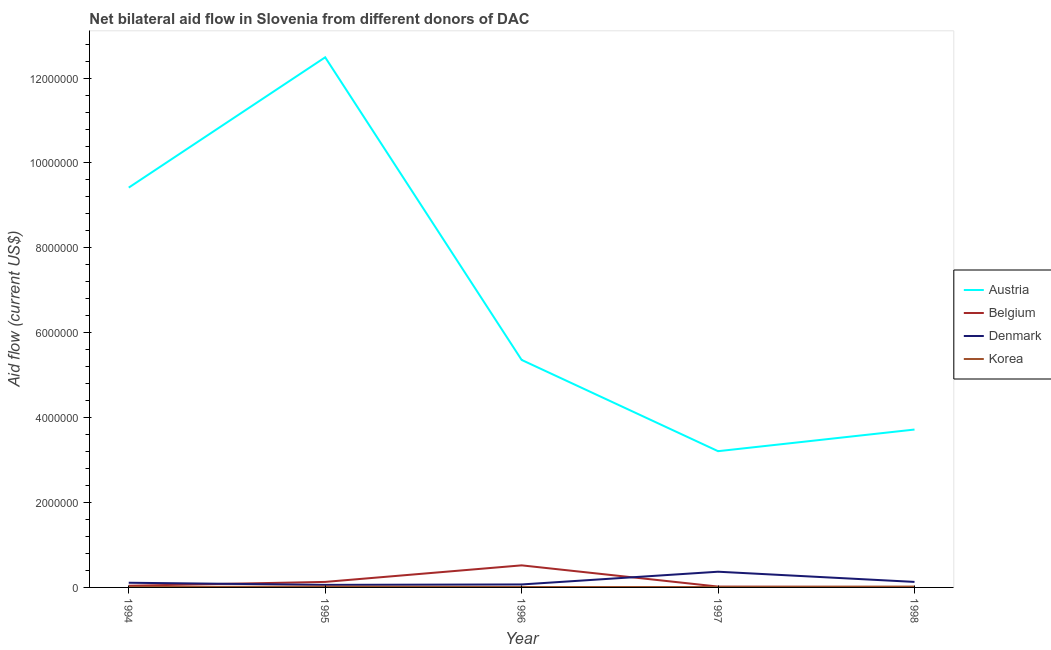Does the line corresponding to amount of aid given by austria intersect with the line corresponding to amount of aid given by korea?
Your answer should be compact. No. Is the number of lines equal to the number of legend labels?
Keep it short and to the point. Yes. What is the amount of aid given by austria in 1995?
Your answer should be compact. 1.25e+07. Across all years, what is the maximum amount of aid given by austria?
Make the answer very short. 1.25e+07. Across all years, what is the minimum amount of aid given by korea?
Your answer should be very brief. 10000. In which year was the amount of aid given by austria maximum?
Your answer should be very brief. 1995. What is the total amount of aid given by austria in the graph?
Provide a short and direct response. 3.42e+07. What is the difference between the amount of aid given by austria in 1996 and that in 1998?
Your response must be concise. 1.64e+06. What is the difference between the amount of aid given by denmark in 1996 and the amount of aid given by korea in 1994?
Ensure brevity in your answer.  6.00e+04. What is the average amount of aid given by austria per year?
Give a very brief answer. 6.84e+06. In the year 1997, what is the difference between the amount of aid given by korea and amount of aid given by belgium?
Offer a very short reply. -10000. What is the ratio of the amount of aid given by austria in 1994 to that in 1995?
Your answer should be compact. 0.75. Is the amount of aid given by belgium in 1994 less than that in 1998?
Ensure brevity in your answer.  No. What is the difference between the highest and the second highest amount of aid given by austria?
Give a very brief answer. 3.07e+06. What is the difference between the highest and the lowest amount of aid given by austria?
Provide a short and direct response. 9.28e+06. In how many years, is the amount of aid given by austria greater than the average amount of aid given by austria taken over all years?
Ensure brevity in your answer.  2. How are the legend labels stacked?
Your answer should be very brief. Vertical. What is the title of the graph?
Offer a terse response. Net bilateral aid flow in Slovenia from different donors of DAC. What is the label or title of the X-axis?
Provide a succinct answer. Year. What is the label or title of the Y-axis?
Offer a very short reply. Aid flow (current US$). What is the Aid flow (current US$) of Austria in 1994?
Ensure brevity in your answer.  9.42e+06. What is the Aid flow (current US$) in Austria in 1995?
Give a very brief answer. 1.25e+07. What is the Aid flow (current US$) of Denmark in 1995?
Provide a succinct answer. 6.00e+04. What is the Aid flow (current US$) of Korea in 1995?
Keep it short and to the point. 2.00e+04. What is the Aid flow (current US$) in Austria in 1996?
Your answer should be compact. 5.36e+06. What is the Aid flow (current US$) in Belgium in 1996?
Your answer should be compact. 5.20e+05. What is the Aid flow (current US$) of Denmark in 1996?
Ensure brevity in your answer.  7.00e+04. What is the Aid flow (current US$) in Austria in 1997?
Give a very brief answer. 3.21e+06. What is the Aid flow (current US$) of Korea in 1997?
Your answer should be very brief. 10000. What is the Aid flow (current US$) in Austria in 1998?
Keep it short and to the point. 3.72e+06. What is the Aid flow (current US$) of Korea in 1998?
Provide a short and direct response. 2.00e+04. Across all years, what is the maximum Aid flow (current US$) in Austria?
Provide a short and direct response. 1.25e+07. Across all years, what is the maximum Aid flow (current US$) in Belgium?
Your response must be concise. 5.20e+05. Across all years, what is the maximum Aid flow (current US$) of Denmark?
Your answer should be very brief. 3.70e+05. Across all years, what is the minimum Aid flow (current US$) of Austria?
Your answer should be compact. 3.21e+06. Across all years, what is the minimum Aid flow (current US$) of Belgium?
Make the answer very short. 10000. Across all years, what is the minimum Aid flow (current US$) in Denmark?
Provide a short and direct response. 6.00e+04. What is the total Aid flow (current US$) in Austria in the graph?
Offer a terse response. 3.42e+07. What is the total Aid flow (current US$) of Belgium in the graph?
Provide a short and direct response. 7.20e+05. What is the total Aid flow (current US$) in Denmark in the graph?
Your response must be concise. 7.40e+05. What is the difference between the Aid flow (current US$) in Austria in 1994 and that in 1995?
Offer a very short reply. -3.07e+06. What is the difference between the Aid flow (current US$) of Belgium in 1994 and that in 1995?
Ensure brevity in your answer.  -9.00e+04. What is the difference between the Aid flow (current US$) of Korea in 1994 and that in 1995?
Keep it short and to the point. -10000. What is the difference between the Aid flow (current US$) of Austria in 1994 and that in 1996?
Give a very brief answer. 4.06e+06. What is the difference between the Aid flow (current US$) in Belgium in 1994 and that in 1996?
Provide a succinct answer. -4.80e+05. What is the difference between the Aid flow (current US$) in Denmark in 1994 and that in 1996?
Ensure brevity in your answer.  4.00e+04. What is the difference between the Aid flow (current US$) in Korea in 1994 and that in 1996?
Keep it short and to the point. 0. What is the difference between the Aid flow (current US$) in Austria in 1994 and that in 1997?
Your response must be concise. 6.21e+06. What is the difference between the Aid flow (current US$) in Belgium in 1994 and that in 1997?
Your response must be concise. 2.00e+04. What is the difference between the Aid flow (current US$) in Austria in 1994 and that in 1998?
Make the answer very short. 5.70e+06. What is the difference between the Aid flow (current US$) in Austria in 1995 and that in 1996?
Offer a terse response. 7.13e+06. What is the difference between the Aid flow (current US$) in Belgium in 1995 and that in 1996?
Give a very brief answer. -3.90e+05. What is the difference between the Aid flow (current US$) in Austria in 1995 and that in 1997?
Keep it short and to the point. 9.28e+06. What is the difference between the Aid flow (current US$) of Belgium in 1995 and that in 1997?
Your answer should be compact. 1.10e+05. What is the difference between the Aid flow (current US$) of Denmark in 1995 and that in 1997?
Provide a short and direct response. -3.10e+05. What is the difference between the Aid flow (current US$) in Austria in 1995 and that in 1998?
Your answer should be compact. 8.77e+06. What is the difference between the Aid flow (current US$) of Belgium in 1995 and that in 1998?
Your answer should be very brief. 1.20e+05. What is the difference between the Aid flow (current US$) in Korea in 1995 and that in 1998?
Make the answer very short. 0. What is the difference between the Aid flow (current US$) of Austria in 1996 and that in 1997?
Provide a short and direct response. 2.15e+06. What is the difference between the Aid flow (current US$) of Denmark in 1996 and that in 1997?
Give a very brief answer. -3.00e+05. What is the difference between the Aid flow (current US$) of Korea in 1996 and that in 1997?
Your answer should be very brief. 0. What is the difference between the Aid flow (current US$) of Austria in 1996 and that in 1998?
Ensure brevity in your answer.  1.64e+06. What is the difference between the Aid flow (current US$) in Belgium in 1996 and that in 1998?
Provide a short and direct response. 5.10e+05. What is the difference between the Aid flow (current US$) of Denmark in 1996 and that in 1998?
Your response must be concise. -6.00e+04. What is the difference between the Aid flow (current US$) of Korea in 1996 and that in 1998?
Your answer should be very brief. -10000. What is the difference between the Aid flow (current US$) in Austria in 1997 and that in 1998?
Your answer should be compact. -5.10e+05. What is the difference between the Aid flow (current US$) in Belgium in 1997 and that in 1998?
Offer a terse response. 10000. What is the difference between the Aid flow (current US$) in Austria in 1994 and the Aid flow (current US$) in Belgium in 1995?
Your response must be concise. 9.29e+06. What is the difference between the Aid flow (current US$) in Austria in 1994 and the Aid flow (current US$) in Denmark in 1995?
Keep it short and to the point. 9.36e+06. What is the difference between the Aid flow (current US$) in Austria in 1994 and the Aid flow (current US$) in Korea in 1995?
Your answer should be compact. 9.40e+06. What is the difference between the Aid flow (current US$) of Austria in 1994 and the Aid flow (current US$) of Belgium in 1996?
Offer a very short reply. 8.90e+06. What is the difference between the Aid flow (current US$) in Austria in 1994 and the Aid flow (current US$) in Denmark in 1996?
Keep it short and to the point. 9.35e+06. What is the difference between the Aid flow (current US$) in Austria in 1994 and the Aid flow (current US$) in Korea in 1996?
Make the answer very short. 9.41e+06. What is the difference between the Aid flow (current US$) in Belgium in 1994 and the Aid flow (current US$) in Korea in 1996?
Provide a short and direct response. 3.00e+04. What is the difference between the Aid flow (current US$) in Denmark in 1994 and the Aid flow (current US$) in Korea in 1996?
Offer a very short reply. 1.00e+05. What is the difference between the Aid flow (current US$) of Austria in 1994 and the Aid flow (current US$) of Belgium in 1997?
Give a very brief answer. 9.40e+06. What is the difference between the Aid flow (current US$) of Austria in 1994 and the Aid flow (current US$) of Denmark in 1997?
Your answer should be compact. 9.05e+06. What is the difference between the Aid flow (current US$) of Austria in 1994 and the Aid flow (current US$) of Korea in 1997?
Give a very brief answer. 9.41e+06. What is the difference between the Aid flow (current US$) of Belgium in 1994 and the Aid flow (current US$) of Denmark in 1997?
Keep it short and to the point. -3.30e+05. What is the difference between the Aid flow (current US$) of Belgium in 1994 and the Aid flow (current US$) of Korea in 1997?
Give a very brief answer. 3.00e+04. What is the difference between the Aid flow (current US$) of Denmark in 1994 and the Aid flow (current US$) of Korea in 1997?
Offer a very short reply. 1.00e+05. What is the difference between the Aid flow (current US$) of Austria in 1994 and the Aid flow (current US$) of Belgium in 1998?
Offer a terse response. 9.41e+06. What is the difference between the Aid flow (current US$) of Austria in 1994 and the Aid flow (current US$) of Denmark in 1998?
Your answer should be very brief. 9.29e+06. What is the difference between the Aid flow (current US$) of Austria in 1994 and the Aid flow (current US$) of Korea in 1998?
Your response must be concise. 9.40e+06. What is the difference between the Aid flow (current US$) in Austria in 1995 and the Aid flow (current US$) in Belgium in 1996?
Ensure brevity in your answer.  1.20e+07. What is the difference between the Aid flow (current US$) in Austria in 1995 and the Aid flow (current US$) in Denmark in 1996?
Provide a short and direct response. 1.24e+07. What is the difference between the Aid flow (current US$) in Austria in 1995 and the Aid flow (current US$) in Korea in 1996?
Offer a terse response. 1.25e+07. What is the difference between the Aid flow (current US$) in Austria in 1995 and the Aid flow (current US$) in Belgium in 1997?
Your answer should be very brief. 1.25e+07. What is the difference between the Aid flow (current US$) of Austria in 1995 and the Aid flow (current US$) of Denmark in 1997?
Provide a succinct answer. 1.21e+07. What is the difference between the Aid flow (current US$) of Austria in 1995 and the Aid flow (current US$) of Korea in 1997?
Your answer should be very brief. 1.25e+07. What is the difference between the Aid flow (current US$) of Belgium in 1995 and the Aid flow (current US$) of Korea in 1997?
Give a very brief answer. 1.20e+05. What is the difference between the Aid flow (current US$) of Austria in 1995 and the Aid flow (current US$) of Belgium in 1998?
Ensure brevity in your answer.  1.25e+07. What is the difference between the Aid flow (current US$) of Austria in 1995 and the Aid flow (current US$) of Denmark in 1998?
Provide a succinct answer. 1.24e+07. What is the difference between the Aid flow (current US$) in Austria in 1995 and the Aid flow (current US$) in Korea in 1998?
Offer a terse response. 1.25e+07. What is the difference between the Aid flow (current US$) in Denmark in 1995 and the Aid flow (current US$) in Korea in 1998?
Ensure brevity in your answer.  4.00e+04. What is the difference between the Aid flow (current US$) of Austria in 1996 and the Aid flow (current US$) of Belgium in 1997?
Offer a very short reply. 5.34e+06. What is the difference between the Aid flow (current US$) in Austria in 1996 and the Aid flow (current US$) in Denmark in 1997?
Ensure brevity in your answer.  4.99e+06. What is the difference between the Aid flow (current US$) of Austria in 1996 and the Aid flow (current US$) of Korea in 1997?
Make the answer very short. 5.35e+06. What is the difference between the Aid flow (current US$) in Belgium in 1996 and the Aid flow (current US$) in Denmark in 1997?
Provide a succinct answer. 1.50e+05. What is the difference between the Aid flow (current US$) of Belgium in 1996 and the Aid flow (current US$) of Korea in 1997?
Provide a short and direct response. 5.10e+05. What is the difference between the Aid flow (current US$) in Denmark in 1996 and the Aid flow (current US$) in Korea in 1997?
Your answer should be very brief. 6.00e+04. What is the difference between the Aid flow (current US$) of Austria in 1996 and the Aid flow (current US$) of Belgium in 1998?
Offer a very short reply. 5.35e+06. What is the difference between the Aid flow (current US$) in Austria in 1996 and the Aid flow (current US$) in Denmark in 1998?
Your answer should be very brief. 5.23e+06. What is the difference between the Aid flow (current US$) in Austria in 1996 and the Aid flow (current US$) in Korea in 1998?
Make the answer very short. 5.34e+06. What is the difference between the Aid flow (current US$) of Austria in 1997 and the Aid flow (current US$) of Belgium in 1998?
Offer a terse response. 3.20e+06. What is the difference between the Aid flow (current US$) of Austria in 1997 and the Aid flow (current US$) of Denmark in 1998?
Keep it short and to the point. 3.08e+06. What is the difference between the Aid flow (current US$) of Austria in 1997 and the Aid flow (current US$) of Korea in 1998?
Your response must be concise. 3.19e+06. What is the difference between the Aid flow (current US$) of Denmark in 1997 and the Aid flow (current US$) of Korea in 1998?
Give a very brief answer. 3.50e+05. What is the average Aid flow (current US$) of Austria per year?
Ensure brevity in your answer.  6.84e+06. What is the average Aid flow (current US$) of Belgium per year?
Ensure brevity in your answer.  1.44e+05. What is the average Aid flow (current US$) in Denmark per year?
Keep it short and to the point. 1.48e+05. What is the average Aid flow (current US$) of Korea per year?
Provide a succinct answer. 1.40e+04. In the year 1994, what is the difference between the Aid flow (current US$) in Austria and Aid flow (current US$) in Belgium?
Give a very brief answer. 9.38e+06. In the year 1994, what is the difference between the Aid flow (current US$) of Austria and Aid flow (current US$) of Denmark?
Ensure brevity in your answer.  9.31e+06. In the year 1994, what is the difference between the Aid flow (current US$) of Austria and Aid flow (current US$) of Korea?
Make the answer very short. 9.41e+06. In the year 1994, what is the difference between the Aid flow (current US$) in Belgium and Aid flow (current US$) in Korea?
Offer a terse response. 3.00e+04. In the year 1994, what is the difference between the Aid flow (current US$) of Denmark and Aid flow (current US$) of Korea?
Provide a succinct answer. 1.00e+05. In the year 1995, what is the difference between the Aid flow (current US$) of Austria and Aid flow (current US$) of Belgium?
Your answer should be very brief. 1.24e+07. In the year 1995, what is the difference between the Aid flow (current US$) of Austria and Aid flow (current US$) of Denmark?
Keep it short and to the point. 1.24e+07. In the year 1995, what is the difference between the Aid flow (current US$) in Austria and Aid flow (current US$) in Korea?
Offer a terse response. 1.25e+07. In the year 1995, what is the difference between the Aid flow (current US$) in Belgium and Aid flow (current US$) in Denmark?
Make the answer very short. 7.00e+04. In the year 1995, what is the difference between the Aid flow (current US$) of Denmark and Aid flow (current US$) of Korea?
Keep it short and to the point. 4.00e+04. In the year 1996, what is the difference between the Aid flow (current US$) in Austria and Aid flow (current US$) in Belgium?
Your answer should be compact. 4.84e+06. In the year 1996, what is the difference between the Aid flow (current US$) in Austria and Aid flow (current US$) in Denmark?
Your response must be concise. 5.29e+06. In the year 1996, what is the difference between the Aid flow (current US$) in Austria and Aid flow (current US$) in Korea?
Offer a very short reply. 5.35e+06. In the year 1996, what is the difference between the Aid flow (current US$) of Belgium and Aid flow (current US$) of Denmark?
Provide a short and direct response. 4.50e+05. In the year 1996, what is the difference between the Aid flow (current US$) in Belgium and Aid flow (current US$) in Korea?
Offer a terse response. 5.10e+05. In the year 1997, what is the difference between the Aid flow (current US$) in Austria and Aid flow (current US$) in Belgium?
Give a very brief answer. 3.19e+06. In the year 1997, what is the difference between the Aid flow (current US$) of Austria and Aid flow (current US$) of Denmark?
Your answer should be compact. 2.84e+06. In the year 1997, what is the difference between the Aid flow (current US$) of Austria and Aid flow (current US$) of Korea?
Keep it short and to the point. 3.20e+06. In the year 1997, what is the difference between the Aid flow (current US$) of Belgium and Aid flow (current US$) of Denmark?
Your response must be concise. -3.50e+05. In the year 1998, what is the difference between the Aid flow (current US$) of Austria and Aid flow (current US$) of Belgium?
Offer a very short reply. 3.71e+06. In the year 1998, what is the difference between the Aid flow (current US$) of Austria and Aid flow (current US$) of Denmark?
Provide a succinct answer. 3.59e+06. In the year 1998, what is the difference between the Aid flow (current US$) of Austria and Aid flow (current US$) of Korea?
Your response must be concise. 3.70e+06. In the year 1998, what is the difference between the Aid flow (current US$) of Belgium and Aid flow (current US$) of Denmark?
Make the answer very short. -1.20e+05. In the year 1998, what is the difference between the Aid flow (current US$) of Belgium and Aid flow (current US$) of Korea?
Your answer should be very brief. -10000. In the year 1998, what is the difference between the Aid flow (current US$) of Denmark and Aid flow (current US$) of Korea?
Give a very brief answer. 1.10e+05. What is the ratio of the Aid flow (current US$) in Austria in 1994 to that in 1995?
Give a very brief answer. 0.75. What is the ratio of the Aid flow (current US$) in Belgium in 1994 to that in 1995?
Keep it short and to the point. 0.31. What is the ratio of the Aid flow (current US$) in Denmark in 1994 to that in 1995?
Provide a short and direct response. 1.83. What is the ratio of the Aid flow (current US$) in Austria in 1994 to that in 1996?
Ensure brevity in your answer.  1.76. What is the ratio of the Aid flow (current US$) in Belgium in 1994 to that in 1996?
Make the answer very short. 0.08. What is the ratio of the Aid flow (current US$) of Denmark in 1994 to that in 1996?
Provide a short and direct response. 1.57. What is the ratio of the Aid flow (current US$) in Korea in 1994 to that in 1996?
Your response must be concise. 1. What is the ratio of the Aid flow (current US$) in Austria in 1994 to that in 1997?
Offer a terse response. 2.93. What is the ratio of the Aid flow (current US$) in Belgium in 1994 to that in 1997?
Provide a succinct answer. 2. What is the ratio of the Aid flow (current US$) of Denmark in 1994 to that in 1997?
Offer a terse response. 0.3. What is the ratio of the Aid flow (current US$) of Korea in 1994 to that in 1997?
Offer a very short reply. 1. What is the ratio of the Aid flow (current US$) in Austria in 1994 to that in 1998?
Keep it short and to the point. 2.53. What is the ratio of the Aid flow (current US$) in Belgium in 1994 to that in 1998?
Offer a very short reply. 4. What is the ratio of the Aid flow (current US$) in Denmark in 1994 to that in 1998?
Offer a terse response. 0.85. What is the ratio of the Aid flow (current US$) in Korea in 1994 to that in 1998?
Give a very brief answer. 0.5. What is the ratio of the Aid flow (current US$) of Austria in 1995 to that in 1996?
Offer a very short reply. 2.33. What is the ratio of the Aid flow (current US$) of Belgium in 1995 to that in 1996?
Provide a succinct answer. 0.25. What is the ratio of the Aid flow (current US$) of Denmark in 1995 to that in 1996?
Your response must be concise. 0.86. What is the ratio of the Aid flow (current US$) in Austria in 1995 to that in 1997?
Your response must be concise. 3.89. What is the ratio of the Aid flow (current US$) of Belgium in 1995 to that in 1997?
Offer a very short reply. 6.5. What is the ratio of the Aid flow (current US$) of Denmark in 1995 to that in 1997?
Provide a short and direct response. 0.16. What is the ratio of the Aid flow (current US$) of Korea in 1995 to that in 1997?
Ensure brevity in your answer.  2. What is the ratio of the Aid flow (current US$) of Austria in 1995 to that in 1998?
Give a very brief answer. 3.36. What is the ratio of the Aid flow (current US$) of Belgium in 1995 to that in 1998?
Offer a terse response. 13. What is the ratio of the Aid flow (current US$) in Denmark in 1995 to that in 1998?
Ensure brevity in your answer.  0.46. What is the ratio of the Aid flow (current US$) of Korea in 1995 to that in 1998?
Offer a terse response. 1. What is the ratio of the Aid flow (current US$) in Austria in 1996 to that in 1997?
Ensure brevity in your answer.  1.67. What is the ratio of the Aid flow (current US$) in Belgium in 1996 to that in 1997?
Give a very brief answer. 26. What is the ratio of the Aid flow (current US$) in Denmark in 1996 to that in 1997?
Make the answer very short. 0.19. What is the ratio of the Aid flow (current US$) in Korea in 1996 to that in 1997?
Your answer should be compact. 1. What is the ratio of the Aid flow (current US$) in Austria in 1996 to that in 1998?
Give a very brief answer. 1.44. What is the ratio of the Aid flow (current US$) of Belgium in 1996 to that in 1998?
Keep it short and to the point. 52. What is the ratio of the Aid flow (current US$) of Denmark in 1996 to that in 1998?
Your answer should be very brief. 0.54. What is the ratio of the Aid flow (current US$) in Austria in 1997 to that in 1998?
Offer a terse response. 0.86. What is the ratio of the Aid flow (current US$) of Denmark in 1997 to that in 1998?
Make the answer very short. 2.85. What is the ratio of the Aid flow (current US$) of Korea in 1997 to that in 1998?
Your answer should be compact. 0.5. What is the difference between the highest and the second highest Aid flow (current US$) of Austria?
Provide a short and direct response. 3.07e+06. What is the difference between the highest and the lowest Aid flow (current US$) in Austria?
Provide a short and direct response. 9.28e+06. What is the difference between the highest and the lowest Aid flow (current US$) of Belgium?
Offer a terse response. 5.10e+05. What is the difference between the highest and the lowest Aid flow (current US$) of Denmark?
Provide a short and direct response. 3.10e+05. What is the difference between the highest and the lowest Aid flow (current US$) in Korea?
Your response must be concise. 10000. 